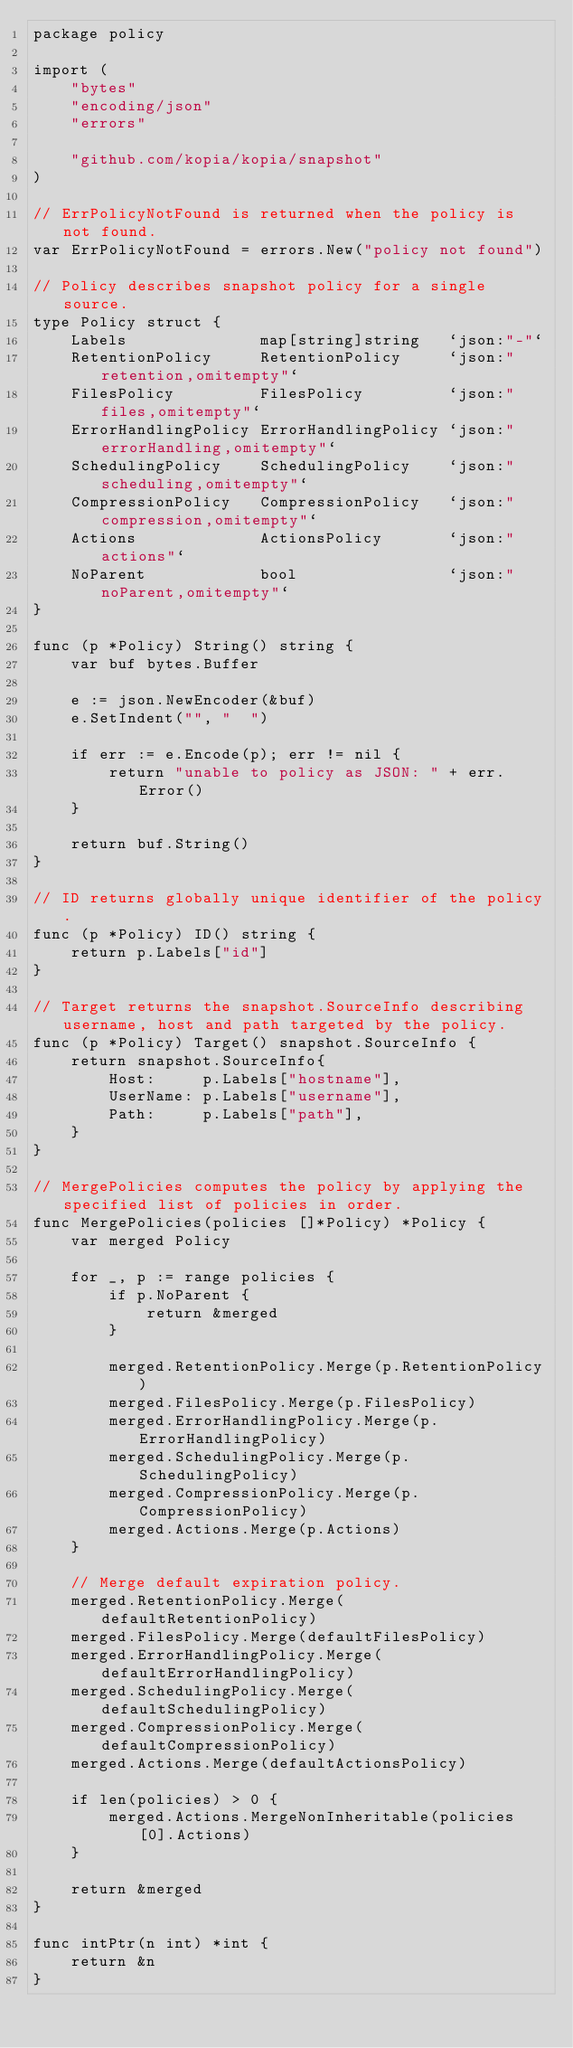Convert code to text. <code><loc_0><loc_0><loc_500><loc_500><_Go_>package policy

import (
	"bytes"
	"encoding/json"
	"errors"

	"github.com/kopia/kopia/snapshot"
)

// ErrPolicyNotFound is returned when the policy is not found.
var ErrPolicyNotFound = errors.New("policy not found")

// Policy describes snapshot policy for a single source.
type Policy struct {
	Labels              map[string]string   `json:"-"`
	RetentionPolicy     RetentionPolicy     `json:"retention,omitempty"`
	FilesPolicy         FilesPolicy         `json:"files,omitempty"`
	ErrorHandlingPolicy ErrorHandlingPolicy `json:"errorHandling,omitempty"`
	SchedulingPolicy    SchedulingPolicy    `json:"scheduling,omitempty"`
	CompressionPolicy   CompressionPolicy   `json:"compression,omitempty"`
	Actions             ActionsPolicy       `json:"actions"`
	NoParent            bool                `json:"noParent,omitempty"`
}

func (p *Policy) String() string {
	var buf bytes.Buffer

	e := json.NewEncoder(&buf)
	e.SetIndent("", "  ")

	if err := e.Encode(p); err != nil {
		return "unable to policy as JSON: " + err.Error()
	}

	return buf.String()
}

// ID returns globally unique identifier of the policy.
func (p *Policy) ID() string {
	return p.Labels["id"]
}

// Target returns the snapshot.SourceInfo describing username, host and path targeted by the policy.
func (p *Policy) Target() snapshot.SourceInfo {
	return snapshot.SourceInfo{
		Host:     p.Labels["hostname"],
		UserName: p.Labels["username"],
		Path:     p.Labels["path"],
	}
}

// MergePolicies computes the policy by applying the specified list of policies in order.
func MergePolicies(policies []*Policy) *Policy {
	var merged Policy

	for _, p := range policies {
		if p.NoParent {
			return &merged
		}

		merged.RetentionPolicy.Merge(p.RetentionPolicy)
		merged.FilesPolicy.Merge(p.FilesPolicy)
		merged.ErrorHandlingPolicy.Merge(p.ErrorHandlingPolicy)
		merged.SchedulingPolicy.Merge(p.SchedulingPolicy)
		merged.CompressionPolicy.Merge(p.CompressionPolicy)
		merged.Actions.Merge(p.Actions)
	}

	// Merge default expiration policy.
	merged.RetentionPolicy.Merge(defaultRetentionPolicy)
	merged.FilesPolicy.Merge(defaultFilesPolicy)
	merged.ErrorHandlingPolicy.Merge(defaultErrorHandlingPolicy)
	merged.SchedulingPolicy.Merge(defaultSchedulingPolicy)
	merged.CompressionPolicy.Merge(defaultCompressionPolicy)
	merged.Actions.Merge(defaultActionsPolicy)

	if len(policies) > 0 {
		merged.Actions.MergeNonInheritable(policies[0].Actions)
	}

	return &merged
}

func intPtr(n int) *int {
	return &n
}
</code> 